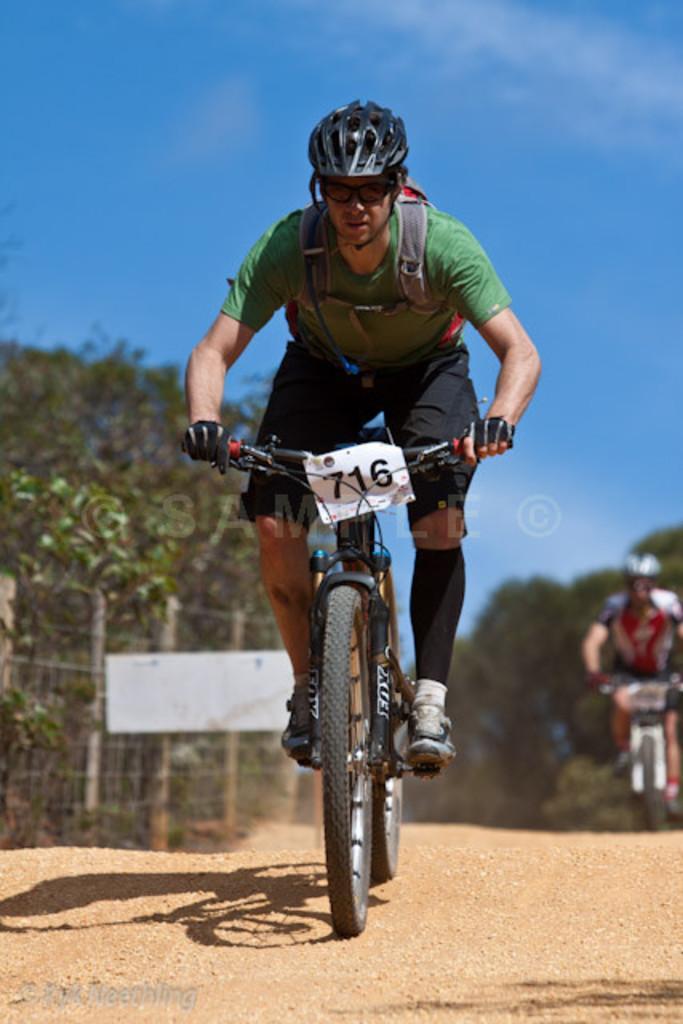Describe this image in one or two sentences. As we can see in the image there is a blue sky, trees and two people riding bicycles 